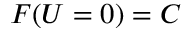Convert formula to latex. <formula><loc_0><loc_0><loc_500><loc_500>F ( U = 0 ) = C</formula> 